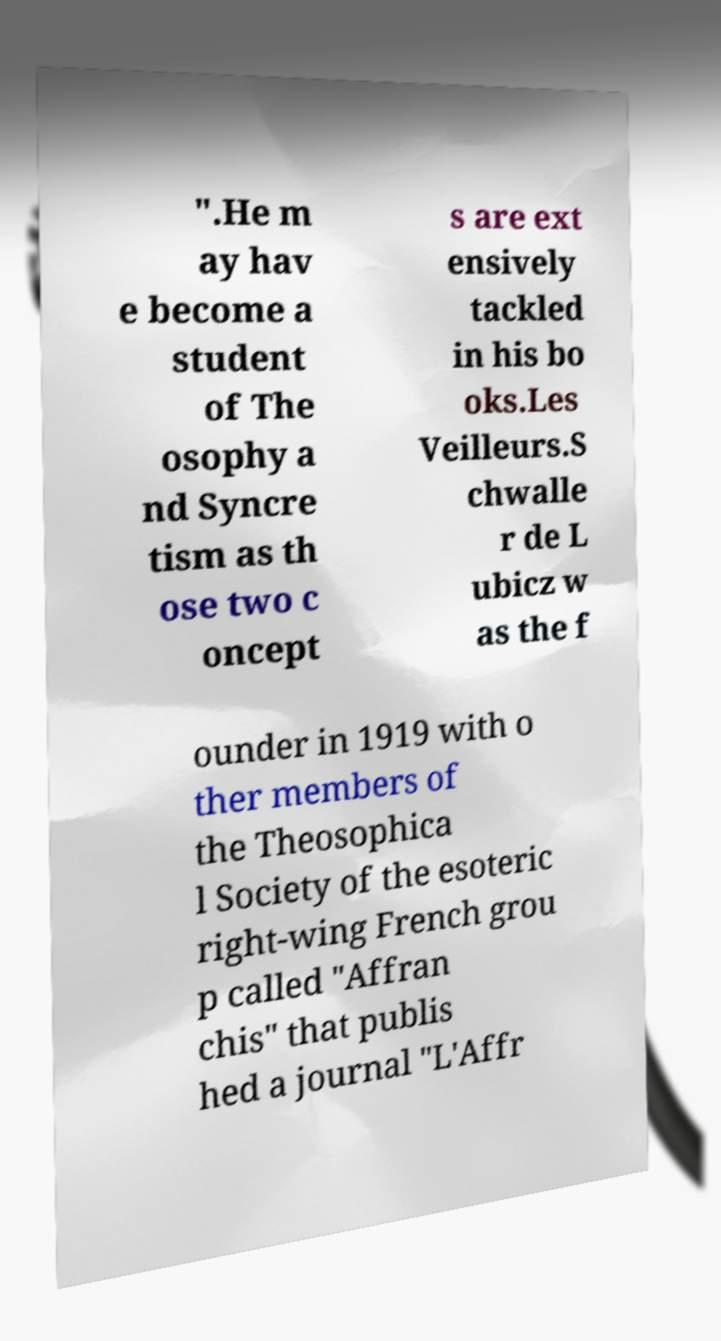Please read and relay the text visible in this image. What does it say? ".He m ay hav e become a student of The osophy a nd Syncre tism as th ose two c oncept s are ext ensively tackled in his bo oks.Les Veilleurs.S chwalle r de L ubicz w as the f ounder in 1919 with o ther members of the Theosophica l Society of the esoteric right-wing French grou p called "Affran chis" that publis hed a journal "L'Affr 